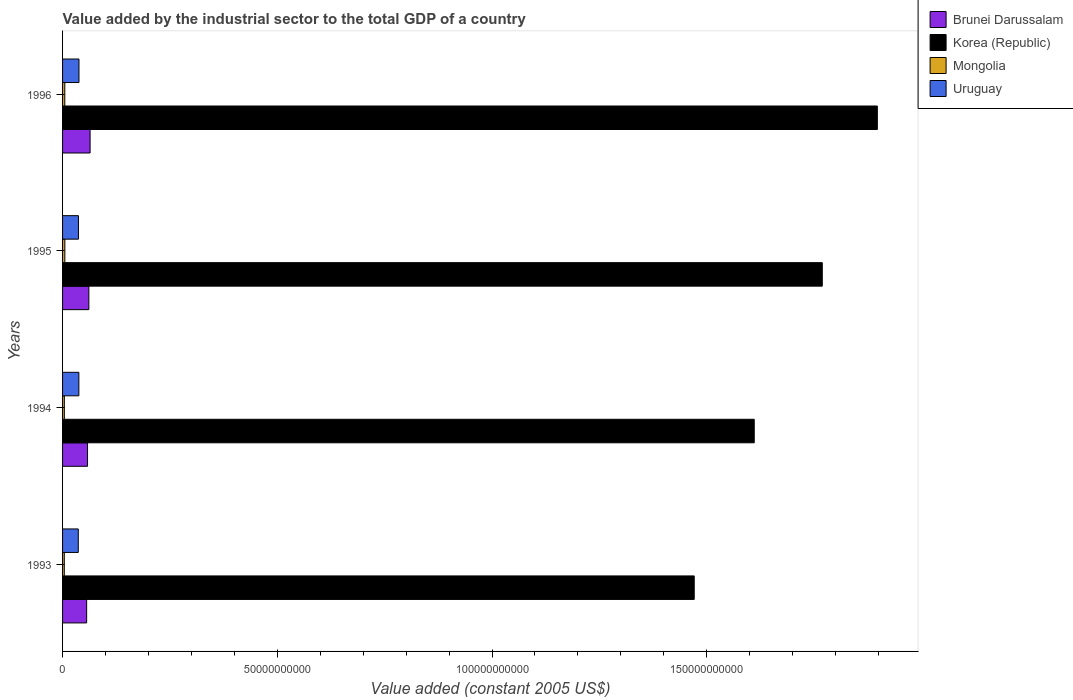How many different coloured bars are there?
Offer a terse response. 4. Are the number of bars per tick equal to the number of legend labels?
Ensure brevity in your answer.  Yes. Are the number of bars on each tick of the Y-axis equal?
Ensure brevity in your answer.  Yes. How many bars are there on the 3rd tick from the bottom?
Ensure brevity in your answer.  4. What is the label of the 3rd group of bars from the top?
Give a very brief answer. 1994. What is the value added by the industrial sector in Korea (Republic) in 1995?
Give a very brief answer. 1.77e+11. Across all years, what is the maximum value added by the industrial sector in Mongolia?
Make the answer very short. 5.31e+08. Across all years, what is the minimum value added by the industrial sector in Uruguay?
Make the answer very short. 3.66e+09. In which year was the value added by the industrial sector in Uruguay maximum?
Provide a succinct answer. 1996. What is the total value added by the industrial sector in Brunei Darussalam in the graph?
Provide a succinct answer. 2.40e+1. What is the difference between the value added by the industrial sector in Mongolia in 1995 and that in 1996?
Make the answer very short. 1.03e+07. What is the difference between the value added by the industrial sector in Korea (Republic) in 1993 and the value added by the industrial sector in Uruguay in 1994?
Your answer should be compact. 1.43e+11. What is the average value added by the industrial sector in Brunei Darussalam per year?
Your answer should be compact. 5.99e+09. In the year 1993, what is the difference between the value added by the industrial sector in Uruguay and value added by the industrial sector in Mongolia?
Keep it short and to the point. 3.25e+09. In how many years, is the value added by the industrial sector in Korea (Republic) greater than 160000000000 US$?
Your answer should be very brief. 3. What is the ratio of the value added by the industrial sector in Mongolia in 1994 to that in 1996?
Your response must be concise. 0.79. Is the difference between the value added by the industrial sector in Uruguay in 1995 and 1996 greater than the difference between the value added by the industrial sector in Mongolia in 1995 and 1996?
Provide a succinct answer. No. What is the difference between the highest and the second highest value added by the industrial sector in Korea (Republic)?
Offer a terse response. 1.28e+1. What is the difference between the highest and the lowest value added by the industrial sector in Mongolia?
Provide a succinct answer. 1.27e+08. What does the 4th bar from the top in 1996 represents?
Your response must be concise. Brunei Darussalam. What does the 4th bar from the bottom in 1994 represents?
Provide a succinct answer. Uruguay. Is it the case that in every year, the sum of the value added by the industrial sector in Mongolia and value added by the industrial sector in Korea (Republic) is greater than the value added by the industrial sector in Brunei Darussalam?
Give a very brief answer. Yes. How many years are there in the graph?
Make the answer very short. 4. What is the difference between two consecutive major ticks on the X-axis?
Your answer should be very brief. 5.00e+1. Does the graph contain any zero values?
Your response must be concise. No. Does the graph contain grids?
Make the answer very short. No. How are the legend labels stacked?
Make the answer very short. Vertical. What is the title of the graph?
Your answer should be compact. Value added by the industrial sector to the total GDP of a country. Does "Pacific island small states" appear as one of the legend labels in the graph?
Make the answer very short. No. What is the label or title of the X-axis?
Offer a terse response. Value added (constant 2005 US$). What is the Value added (constant 2005 US$) of Brunei Darussalam in 1993?
Ensure brevity in your answer.  5.61e+09. What is the Value added (constant 2005 US$) in Korea (Republic) in 1993?
Your answer should be very brief. 1.47e+11. What is the Value added (constant 2005 US$) of Mongolia in 1993?
Make the answer very short. 4.05e+08. What is the Value added (constant 2005 US$) in Uruguay in 1993?
Give a very brief answer. 3.66e+09. What is the Value added (constant 2005 US$) of Brunei Darussalam in 1994?
Your response must be concise. 5.81e+09. What is the Value added (constant 2005 US$) of Korea (Republic) in 1994?
Make the answer very short. 1.61e+11. What is the Value added (constant 2005 US$) of Mongolia in 1994?
Make the answer very short. 4.14e+08. What is the Value added (constant 2005 US$) of Uruguay in 1994?
Your answer should be very brief. 3.79e+09. What is the Value added (constant 2005 US$) of Brunei Darussalam in 1995?
Make the answer very short. 6.12e+09. What is the Value added (constant 2005 US$) in Korea (Republic) in 1995?
Keep it short and to the point. 1.77e+11. What is the Value added (constant 2005 US$) in Mongolia in 1995?
Your response must be concise. 5.31e+08. What is the Value added (constant 2005 US$) of Uruguay in 1995?
Offer a very short reply. 3.70e+09. What is the Value added (constant 2005 US$) of Brunei Darussalam in 1996?
Your answer should be very brief. 6.41e+09. What is the Value added (constant 2005 US$) of Korea (Republic) in 1996?
Your response must be concise. 1.90e+11. What is the Value added (constant 2005 US$) in Mongolia in 1996?
Give a very brief answer. 5.21e+08. What is the Value added (constant 2005 US$) in Uruguay in 1996?
Give a very brief answer. 3.82e+09. Across all years, what is the maximum Value added (constant 2005 US$) in Brunei Darussalam?
Give a very brief answer. 6.41e+09. Across all years, what is the maximum Value added (constant 2005 US$) in Korea (Republic)?
Your answer should be very brief. 1.90e+11. Across all years, what is the maximum Value added (constant 2005 US$) in Mongolia?
Ensure brevity in your answer.  5.31e+08. Across all years, what is the maximum Value added (constant 2005 US$) of Uruguay?
Keep it short and to the point. 3.82e+09. Across all years, what is the minimum Value added (constant 2005 US$) of Brunei Darussalam?
Make the answer very short. 5.61e+09. Across all years, what is the minimum Value added (constant 2005 US$) of Korea (Republic)?
Your answer should be compact. 1.47e+11. Across all years, what is the minimum Value added (constant 2005 US$) in Mongolia?
Provide a short and direct response. 4.05e+08. Across all years, what is the minimum Value added (constant 2005 US$) of Uruguay?
Your response must be concise. 3.66e+09. What is the total Value added (constant 2005 US$) of Brunei Darussalam in the graph?
Offer a very short reply. 2.40e+1. What is the total Value added (constant 2005 US$) in Korea (Republic) in the graph?
Provide a short and direct response. 6.75e+11. What is the total Value added (constant 2005 US$) of Mongolia in the graph?
Your response must be concise. 1.87e+09. What is the total Value added (constant 2005 US$) in Uruguay in the graph?
Offer a very short reply. 1.50e+1. What is the difference between the Value added (constant 2005 US$) of Brunei Darussalam in 1993 and that in 1994?
Make the answer very short. -2.06e+08. What is the difference between the Value added (constant 2005 US$) in Korea (Republic) in 1993 and that in 1994?
Provide a succinct answer. -1.40e+1. What is the difference between the Value added (constant 2005 US$) in Mongolia in 1993 and that in 1994?
Provide a succinct answer. -9.27e+06. What is the difference between the Value added (constant 2005 US$) of Uruguay in 1993 and that in 1994?
Make the answer very short. -1.34e+08. What is the difference between the Value added (constant 2005 US$) of Brunei Darussalam in 1993 and that in 1995?
Provide a succinct answer. -5.17e+08. What is the difference between the Value added (constant 2005 US$) of Korea (Republic) in 1993 and that in 1995?
Your answer should be very brief. -2.98e+1. What is the difference between the Value added (constant 2005 US$) in Mongolia in 1993 and that in 1995?
Your answer should be compact. -1.27e+08. What is the difference between the Value added (constant 2005 US$) in Uruguay in 1993 and that in 1995?
Offer a terse response. -4.13e+07. What is the difference between the Value added (constant 2005 US$) in Brunei Darussalam in 1993 and that in 1996?
Ensure brevity in your answer.  -8.02e+08. What is the difference between the Value added (constant 2005 US$) of Korea (Republic) in 1993 and that in 1996?
Provide a succinct answer. -4.26e+1. What is the difference between the Value added (constant 2005 US$) in Mongolia in 1993 and that in 1996?
Ensure brevity in your answer.  -1.17e+08. What is the difference between the Value added (constant 2005 US$) of Uruguay in 1993 and that in 1996?
Your answer should be very brief. -1.65e+08. What is the difference between the Value added (constant 2005 US$) of Brunei Darussalam in 1994 and that in 1995?
Provide a succinct answer. -3.11e+08. What is the difference between the Value added (constant 2005 US$) in Korea (Republic) in 1994 and that in 1995?
Provide a succinct answer. -1.58e+1. What is the difference between the Value added (constant 2005 US$) in Mongolia in 1994 and that in 1995?
Your response must be concise. -1.18e+08. What is the difference between the Value added (constant 2005 US$) of Uruguay in 1994 and that in 1995?
Offer a terse response. 9.31e+07. What is the difference between the Value added (constant 2005 US$) in Brunei Darussalam in 1994 and that in 1996?
Ensure brevity in your answer.  -5.96e+08. What is the difference between the Value added (constant 2005 US$) in Korea (Republic) in 1994 and that in 1996?
Ensure brevity in your answer.  -2.87e+1. What is the difference between the Value added (constant 2005 US$) in Mongolia in 1994 and that in 1996?
Provide a short and direct response. -1.07e+08. What is the difference between the Value added (constant 2005 US$) in Uruguay in 1994 and that in 1996?
Provide a short and direct response. -3.06e+07. What is the difference between the Value added (constant 2005 US$) in Brunei Darussalam in 1995 and that in 1996?
Your answer should be compact. -2.85e+08. What is the difference between the Value added (constant 2005 US$) of Korea (Republic) in 1995 and that in 1996?
Your response must be concise. -1.28e+1. What is the difference between the Value added (constant 2005 US$) of Mongolia in 1995 and that in 1996?
Ensure brevity in your answer.  1.03e+07. What is the difference between the Value added (constant 2005 US$) of Uruguay in 1995 and that in 1996?
Ensure brevity in your answer.  -1.24e+08. What is the difference between the Value added (constant 2005 US$) in Brunei Darussalam in 1993 and the Value added (constant 2005 US$) in Korea (Republic) in 1994?
Your answer should be compact. -1.55e+11. What is the difference between the Value added (constant 2005 US$) of Brunei Darussalam in 1993 and the Value added (constant 2005 US$) of Mongolia in 1994?
Your answer should be very brief. 5.19e+09. What is the difference between the Value added (constant 2005 US$) in Brunei Darussalam in 1993 and the Value added (constant 2005 US$) in Uruguay in 1994?
Your answer should be very brief. 1.81e+09. What is the difference between the Value added (constant 2005 US$) in Korea (Republic) in 1993 and the Value added (constant 2005 US$) in Mongolia in 1994?
Provide a short and direct response. 1.47e+11. What is the difference between the Value added (constant 2005 US$) of Korea (Republic) in 1993 and the Value added (constant 2005 US$) of Uruguay in 1994?
Offer a very short reply. 1.43e+11. What is the difference between the Value added (constant 2005 US$) in Mongolia in 1993 and the Value added (constant 2005 US$) in Uruguay in 1994?
Your answer should be compact. -3.39e+09. What is the difference between the Value added (constant 2005 US$) of Brunei Darussalam in 1993 and the Value added (constant 2005 US$) of Korea (Republic) in 1995?
Your answer should be very brief. -1.71e+11. What is the difference between the Value added (constant 2005 US$) in Brunei Darussalam in 1993 and the Value added (constant 2005 US$) in Mongolia in 1995?
Give a very brief answer. 5.07e+09. What is the difference between the Value added (constant 2005 US$) of Brunei Darussalam in 1993 and the Value added (constant 2005 US$) of Uruguay in 1995?
Provide a succinct answer. 1.91e+09. What is the difference between the Value added (constant 2005 US$) in Korea (Republic) in 1993 and the Value added (constant 2005 US$) in Mongolia in 1995?
Keep it short and to the point. 1.47e+11. What is the difference between the Value added (constant 2005 US$) of Korea (Republic) in 1993 and the Value added (constant 2005 US$) of Uruguay in 1995?
Your response must be concise. 1.43e+11. What is the difference between the Value added (constant 2005 US$) in Mongolia in 1993 and the Value added (constant 2005 US$) in Uruguay in 1995?
Make the answer very short. -3.30e+09. What is the difference between the Value added (constant 2005 US$) in Brunei Darussalam in 1993 and the Value added (constant 2005 US$) in Korea (Republic) in 1996?
Provide a succinct answer. -1.84e+11. What is the difference between the Value added (constant 2005 US$) in Brunei Darussalam in 1993 and the Value added (constant 2005 US$) in Mongolia in 1996?
Make the answer very short. 5.09e+09. What is the difference between the Value added (constant 2005 US$) of Brunei Darussalam in 1993 and the Value added (constant 2005 US$) of Uruguay in 1996?
Provide a short and direct response. 1.78e+09. What is the difference between the Value added (constant 2005 US$) of Korea (Republic) in 1993 and the Value added (constant 2005 US$) of Mongolia in 1996?
Your response must be concise. 1.47e+11. What is the difference between the Value added (constant 2005 US$) in Korea (Republic) in 1993 and the Value added (constant 2005 US$) in Uruguay in 1996?
Your answer should be very brief. 1.43e+11. What is the difference between the Value added (constant 2005 US$) of Mongolia in 1993 and the Value added (constant 2005 US$) of Uruguay in 1996?
Offer a very short reply. -3.42e+09. What is the difference between the Value added (constant 2005 US$) in Brunei Darussalam in 1994 and the Value added (constant 2005 US$) in Korea (Republic) in 1995?
Keep it short and to the point. -1.71e+11. What is the difference between the Value added (constant 2005 US$) in Brunei Darussalam in 1994 and the Value added (constant 2005 US$) in Mongolia in 1995?
Give a very brief answer. 5.28e+09. What is the difference between the Value added (constant 2005 US$) in Brunei Darussalam in 1994 and the Value added (constant 2005 US$) in Uruguay in 1995?
Provide a short and direct response. 2.11e+09. What is the difference between the Value added (constant 2005 US$) of Korea (Republic) in 1994 and the Value added (constant 2005 US$) of Mongolia in 1995?
Keep it short and to the point. 1.61e+11. What is the difference between the Value added (constant 2005 US$) in Korea (Republic) in 1994 and the Value added (constant 2005 US$) in Uruguay in 1995?
Give a very brief answer. 1.57e+11. What is the difference between the Value added (constant 2005 US$) of Mongolia in 1994 and the Value added (constant 2005 US$) of Uruguay in 1995?
Provide a succinct answer. -3.29e+09. What is the difference between the Value added (constant 2005 US$) in Brunei Darussalam in 1994 and the Value added (constant 2005 US$) in Korea (Republic) in 1996?
Offer a terse response. -1.84e+11. What is the difference between the Value added (constant 2005 US$) of Brunei Darussalam in 1994 and the Value added (constant 2005 US$) of Mongolia in 1996?
Ensure brevity in your answer.  5.29e+09. What is the difference between the Value added (constant 2005 US$) of Brunei Darussalam in 1994 and the Value added (constant 2005 US$) of Uruguay in 1996?
Keep it short and to the point. 1.99e+09. What is the difference between the Value added (constant 2005 US$) of Korea (Republic) in 1994 and the Value added (constant 2005 US$) of Mongolia in 1996?
Offer a terse response. 1.61e+11. What is the difference between the Value added (constant 2005 US$) of Korea (Republic) in 1994 and the Value added (constant 2005 US$) of Uruguay in 1996?
Ensure brevity in your answer.  1.57e+11. What is the difference between the Value added (constant 2005 US$) in Mongolia in 1994 and the Value added (constant 2005 US$) in Uruguay in 1996?
Offer a very short reply. -3.41e+09. What is the difference between the Value added (constant 2005 US$) of Brunei Darussalam in 1995 and the Value added (constant 2005 US$) of Korea (Republic) in 1996?
Ensure brevity in your answer.  -1.84e+11. What is the difference between the Value added (constant 2005 US$) of Brunei Darussalam in 1995 and the Value added (constant 2005 US$) of Mongolia in 1996?
Make the answer very short. 5.60e+09. What is the difference between the Value added (constant 2005 US$) of Brunei Darussalam in 1995 and the Value added (constant 2005 US$) of Uruguay in 1996?
Provide a short and direct response. 2.30e+09. What is the difference between the Value added (constant 2005 US$) of Korea (Republic) in 1995 and the Value added (constant 2005 US$) of Mongolia in 1996?
Provide a short and direct response. 1.76e+11. What is the difference between the Value added (constant 2005 US$) of Korea (Republic) in 1995 and the Value added (constant 2005 US$) of Uruguay in 1996?
Your answer should be compact. 1.73e+11. What is the difference between the Value added (constant 2005 US$) of Mongolia in 1995 and the Value added (constant 2005 US$) of Uruguay in 1996?
Your response must be concise. -3.29e+09. What is the average Value added (constant 2005 US$) of Brunei Darussalam per year?
Your answer should be compact. 5.99e+09. What is the average Value added (constant 2005 US$) in Korea (Republic) per year?
Offer a very short reply. 1.69e+11. What is the average Value added (constant 2005 US$) of Mongolia per year?
Make the answer very short. 4.68e+08. What is the average Value added (constant 2005 US$) of Uruguay per year?
Provide a short and direct response. 3.74e+09. In the year 1993, what is the difference between the Value added (constant 2005 US$) in Brunei Darussalam and Value added (constant 2005 US$) in Korea (Republic)?
Provide a short and direct response. -1.41e+11. In the year 1993, what is the difference between the Value added (constant 2005 US$) in Brunei Darussalam and Value added (constant 2005 US$) in Mongolia?
Your response must be concise. 5.20e+09. In the year 1993, what is the difference between the Value added (constant 2005 US$) in Brunei Darussalam and Value added (constant 2005 US$) in Uruguay?
Your answer should be very brief. 1.95e+09. In the year 1993, what is the difference between the Value added (constant 2005 US$) of Korea (Republic) and Value added (constant 2005 US$) of Mongolia?
Offer a terse response. 1.47e+11. In the year 1993, what is the difference between the Value added (constant 2005 US$) of Korea (Republic) and Value added (constant 2005 US$) of Uruguay?
Offer a very short reply. 1.43e+11. In the year 1993, what is the difference between the Value added (constant 2005 US$) in Mongolia and Value added (constant 2005 US$) in Uruguay?
Keep it short and to the point. -3.25e+09. In the year 1994, what is the difference between the Value added (constant 2005 US$) in Brunei Darussalam and Value added (constant 2005 US$) in Korea (Republic)?
Give a very brief answer. -1.55e+11. In the year 1994, what is the difference between the Value added (constant 2005 US$) of Brunei Darussalam and Value added (constant 2005 US$) of Mongolia?
Keep it short and to the point. 5.40e+09. In the year 1994, what is the difference between the Value added (constant 2005 US$) in Brunei Darussalam and Value added (constant 2005 US$) in Uruguay?
Your answer should be very brief. 2.02e+09. In the year 1994, what is the difference between the Value added (constant 2005 US$) in Korea (Republic) and Value added (constant 2005 US$) in Mongolia?
Make the answer very short. 1.61e+11. In the year 1994, what is the difference between the Value added (constant 2005 US$) in Korea (Republic) and Value added (constant 2005 US$) in Uruguay?
Ensure brevity in your answer.  1.57e+11. In the year 1994, what is the difference between the Value added (constant 2005 US$) of Mongolia and Value added (constant 2005 US$) of Uruguay?
Provide a succinct answer. -3.38e+09. In the year 1995, what is the difference between the Value added (constant 2005 US$) of Brunei Darussalam and Value added (constant 2005 US$) of Korea (Republic)?
Offer a very short reply. -1.71e+11. In the year 1995, what is the difference between the Value added (constant 2005 US$) of Brunei Darussalam and Value added (constant 2005 US$) of Mongolia?
Offer a very short reply. 5.59e+09. In the year 1995, what is the difference between the Value added (constant 2005 US$) of Brunei Darussalam and Value added (constant 2005 US$) of Uruguay?
Your answer should be very brief. 2.42e+09. In the year 1995, what is the difference between the Value added (constant 2005 US$) in Korea (Republic) and Value added (constant 2005 US$) in Mongolia?
Provide a succinct answer. 1.76e+11. In the year 1995, what is the difference between the Value added (constant 2005 US$) of Korea (Republic) and Value added (constant 2005 US$) of Uruguay?
Ensure brevity in your answer.  1.73e+11. In the year 1995, what is the difference between the Value added (constant 2005 US$) in Mongolia and Value added (constant 2005 US$) in Uruguay?
Your answer should be compact. -3.17e+09. In the year 1996, what is the difference between the Value added (constant 2005 US$) of Brunei Darussalam and Value added (constant 2005 US$) of Korea (Republic)?
Make the answer very short. -1.83e+11. In the year 1996, what is the difference between the Value added (constant 2005 US$) of Brunei Darussalam and Value added (constant 2005 US$) of Mongolia?
Ensure brevity in your answer.  5.89e+09. In the year 1996, what is the difference between the Value added (constant 2005 US$) in Brunei Darussalam and Value added (constant 2005 US$) in Uruguay?
Provide a succinct answer. 2.58e+09. In the year 1996, what is the difference between the Value added (constant 2005 US$) of Korea (Republic) and Value added (constant 2005 US$) of Mongolia?
Provide a short and direct response. 1.89e+11. In the year 1996, what is the difference between the Value added (constant 2005 US$) in Korea (Republic) and Value added (constant 2005 US$) in Uruguay?
Provide a succinct answer. 1.86e+11. In the year 1996, what is the difference between the Value added (constant 2005 US$) in Mongolia and Value added (constant 2005 US$) in Uruguay?
Ensure brevity in your answer.  -3.30e+09. What is the ratio of the Value added (constant 2005 US$) of Brunei Darussalam in 1993 to that in 1994?
Your answer should be very brief. 0.96. What is the ratio of the Value added (constant 2005 US$) of Korea (Republic) in 1993 to that in 1994?
Offer a very short reply. 0.91. What is the ratio of the Value added (constant 2005 US$) of Mongolia in 1993 to that in 1994?
Keep it short and to the point. 0.98. What is the ratio of the Value added (constant 2005 US$) in Uruguay in 1993 to that in 1994?
Provide a succinct answer. 0.96. What is the ratio of the Value added (constant 2005 US$) in Brunei Darussalam in 1993 to that in 1995?
Keep it short and to the point. 0.92. What is the ratio of the Value added (constant 2005 US$) of Korea (Republic) in 1993 to that in 1995?
Make the answer very short. 0.83. What is the ratio of the Value added (constant 2005 US$) of Mongolia in 1993 to that in 1995?
Offer a terse response. 0.76. What is the ratio of the Value added (constant 2005 US$) in Brunei Darussalam in 1993 to that in 1996?
Ensure brevity in your answer.  0.87. What is the ratio of the Value added (constant 2005 US$) of Korea (Republic) in 1993 to that in 1996?
Ensure brevity in your answer.  0.78. What is the ratio of the Value added (constant 2005 US$) in Mongolia in 1993 to that in 1996?
Make the answer very short. 0.78. What is the ratio of the Value added (constant 2005 US$) in Uruguay in 1993 to that in 1996?
Keep it short and to the point. 0.96. What is the ratio of the Value added (constant 2005 US$) of Brunei Darussalam in 1994 to that in 1995?
Offer a very short reply. 0.95. What is the ratio of the Value added (constant 2005 US$) in Korea (Republic) in 1994 to that in 1995?
Your response must be concise. 0.91. What is the ratio of the Value added (constant 2005 US$) of Mongolia in 1994 to that in 1995?
Ensure brevity in your answer.  0.78. What is the ratio of the Value added (constant 2005 US$) of Uruguay in 1994 to that in 1995?
Keep it short and to the point. 1.03. What is the ratio of the Value added (constant 2005 US$) in Brunei Darussalam in 1994 to that in 1996?
Offer a very short reply. 0.91. What is the ratio of the Value added (constant 2005 US$) of Korea (Republic) in 1994 to that in 1996?
Ensure brevity in your answer.  0.85. What is the ratio of the Value added (constant 2005 US$) of Mongolia in 1994 to that in 1996?
Provide a short and direct response. 0.79. What is the ratio of the Value added (constant 2005 US$) of Brunei Darussalam in 1995 to that in 1996?
Your answer should be very brief. 0.96. What is the ratio of the Value added (constant 2005 US$) of Korea (Republic) in 1995 to that in 1996?
Keep it short and to the point. 0.93. What is the ratio of the Value added (constant 2005 US$) in Mongolia in 1995 to that in 1996?
Give a very brief answer. 1.02. What is the ratio of the Value added (constant 2005 US$) in Uruguay in 1995 to that in 1996?
Your response must be concise. 0.97. What is the difference between the highest and the second highest Value added (constant 2005 US$) in Brunei Darussalam?
Provide a short and direct response. 2.85e+08. What is the difference between the highest and the second highest Value added (constant 2005 US$) in Korea (Republic)?
Make the answer very short. 1.28e+1. What is the difference between the highest and the second highest Value added (constant 2005 US$) of Mongolia?
Provide a succinct answer. 1.03e+07. What is the difference between the highest and the second highest Value added (constant 2005 US$) of Uruguay?
Give a very brief answer. 3.06e+07. What is the difference between the highest and the lowest Value added (constant 2005 US$) in Brunei Darussalam?
Give a very brief answer. 8.02e+08. What is the difference between the highest and the lowest Value added (constant 2005 US$) in Korea (Republic)?
Provide a succinct answer. 4.26e+1. What is the difference between the highest and the lowest Value added (constant 2005 US$) of Mongolia?
Provide a succinct answer. 1.27e+08. What is the difference between the highest and the lowest Value added (constant 2005 US$) in Uruguay?
Your answer should be very brief. 1.65e+08. 